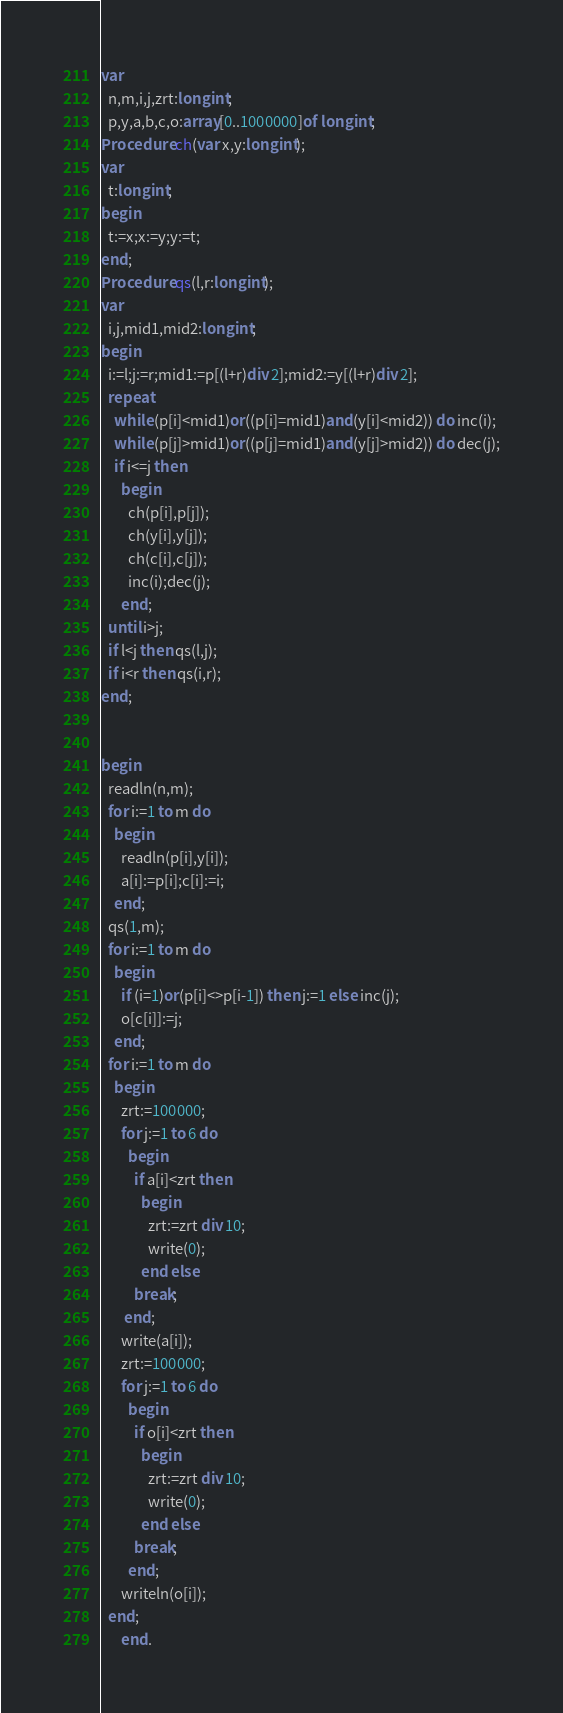<code> <loc_0><loc_0><loc_500><loc_500><_Pascal_>var
  n,m,i,j,zrt:longint;
  p,y,a,b,c,o:array[0..1000000]of longint;
Procedure ch(var x,y:longint);
var
  t:longint;
begin
  t:=x;x:=y;y:=t;
end;
Procedure qs(l,r:longint);
var
  i,j,mid1,mid2:longint;
begin
  i:=l;j:=r;mid1:=p[(l+r)div 2];mid2:=y[(l+r)div 2];
  repeat
    while (p[i]<mid1)or((p[i]=mid1)and(y[i]<mid2)) do inc(i);
    while (p[j]>mid1)or((p[j]=mid1)and(y[j]>mid2)) do dec(j);
    if i<=j then
      begin
        ch(p[i],p[j]);
        ch(y[i],y[j]);
        ch(c[i],c[j]);
        inc(i);dec(j);
      end;
  until i>j;
  if l<j then qs(l,j);
  if i<r then qs(i,r);
end;


begin
  readln(n,m);
  for i:=1 to m do
    begin
      readln(p[i],y[i]);
      a[i]:=p[i];c[i]:=i;
    end;
  qs(1,m);
  for i:=1 to m do
    begin
      if (i=1)or(p[i]<>p[i-1]) then j:=1 else inc(j);
      o[c[i]]:=j;
    end;
  for i:=1 to m do
    begin
      zrt:=100000;
      for j:=1 to 6 do
        begin
          if a[i]<zrt then
            begin
              zrt:=zrt div 10;
              write(0);
            end else
          break;
       end;
      write(a[i]);
      zrt:=100000;
      for j:=1 to 6 do
        begin
          if o[i]<zrt then
            begin
              zrt:=zrt div 10;
              write(0);
            end else
          break;
        end;
      writeln(o[i]);
  end;
      end.
</code> 